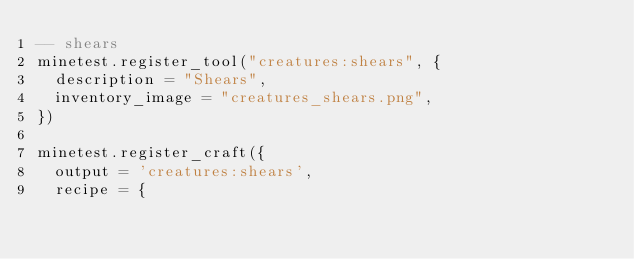<code> <loc_0><loc_0><loc_500><loc_500><_Lua_>-- shears
minetest.register_tool("creatures:shears", {
	description = "Shears",
	inventory_image = "creatures_shears.png",
})

minetest.register_craft({
	output = 'creatures:shears',
	recipe = {</code> 